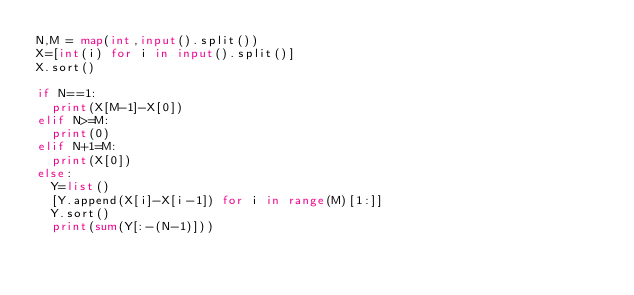Convert code to text. <code><loc_0><loc_0><loc_500><loc_500><_Python_>N,M = map(int,input().split())
X=[int(i) for i in input().split()]
X.sort()

if N==1:
  print(X[M-1]-X[0])
elif N>=M:
  print(0)
elif N+1=M:
  print(X[0])
else:
  Y=list()
  [Y.append(X[i]-X[i-1]) for i in range(M)[1:]]
  Y.sort()
  print(sum(Y[:-(N-1)]))
</code> 